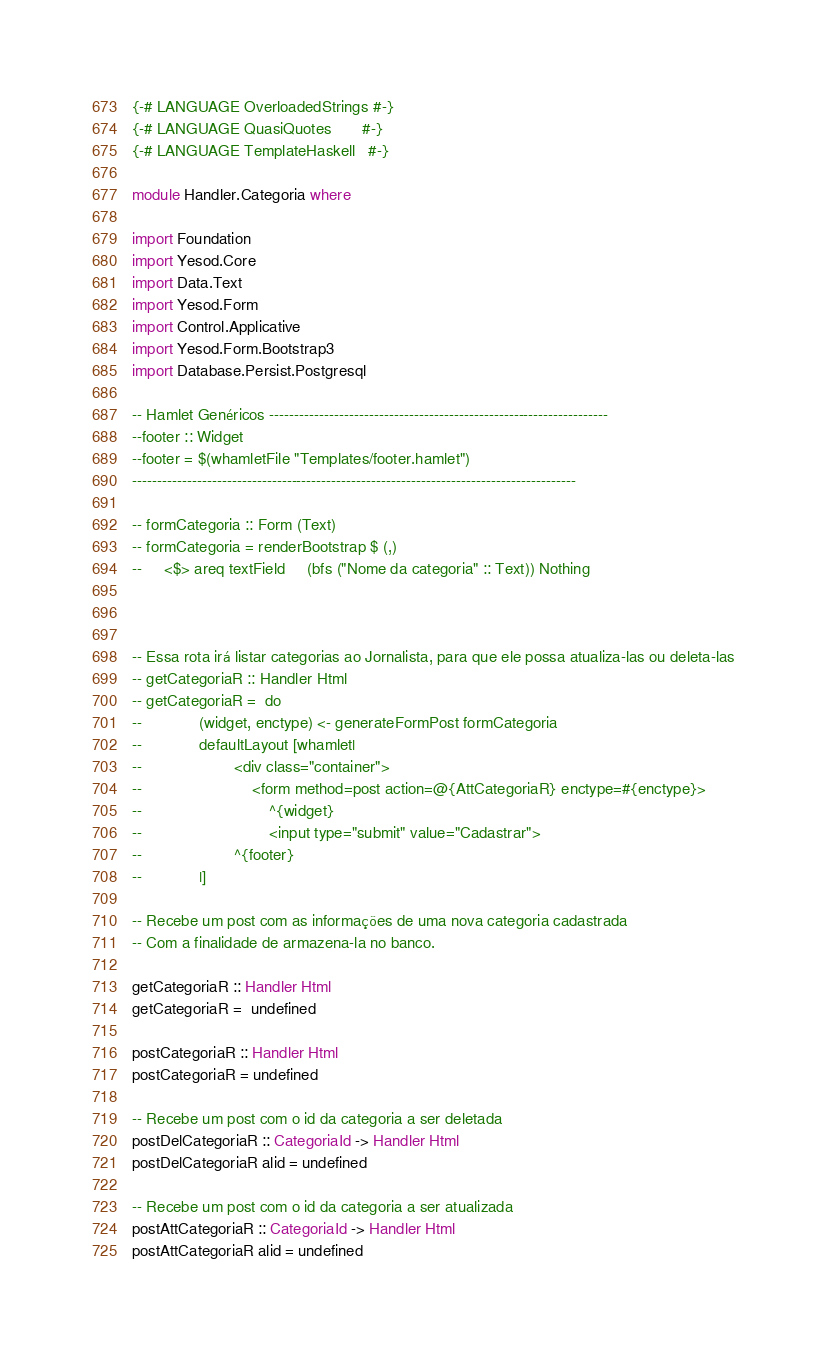Convert code to text. <code><loc_0><loc_0><loc_500><loc_500><_Haskell_>{-# LANGUAGE OverloadedStrings #-}
{-# LANGUAGE QuasiQuotes       #-}
{-# LANGUAGE TemplateHaskell   #-}

module Handler.Categoria where

import Foundation
import Yesod.Core
import Data.Text
import Yesod.Form
import Control.Applicative
import Yesod.Form.Bootstrap3
import Database.Persist.Postgresql

-- Hamlet Genéricos --------------------------------------------------------------------
--footer :: Widget
--footer = $(whamletFile "Templates/footer.hamlet")
-----------------------------------------------------------------------------------------

-- formCategoria :: Form (Text)
-- formCategoria = renderBootstrap $ (,)
--     <$> areq textField     (bfs ("Nome da categoria" :: Text)) Nothing



-- Essa rota irá listar categorias ao Jornalista, para que ele possa atualiza-las ou deleta-las
-- getCategoriaR :: Handler Html
-- getCategoriaR =  do
--             (widget, enctype) <- generateFormPost formCategoria
--             defaultLayout [whamlet|
--                     <div class="container">
--                         <form method=post action=@{AttCategoriaR} enctype=#{enctype}>
--                             ^{widget}
--                             <input type="submit" value="Cadastrar">
--                     ^{footer}
--             |]

-- Recebe um post com as informações de uma nova categoria cadastrada 
-- Com a finalidade de armazena-la no banco.

getCategoriaR :: Handler Html
getCategoriaR =  undefined

postCategoriaR :: Handler Html
postCategoriaR = undefined

-- Recebe um post com o id da categoria a ser deletada
postDelCategoriaR :: CategoriaId -> Handler Html
postDelCategoriaR alid = undefined

-- Recebe um post com o id da categoria a ser atualizada
postAttCategoriaR :: CategoriaId -> Handler Html
postAttCategoriaR alid = undefined</code> 